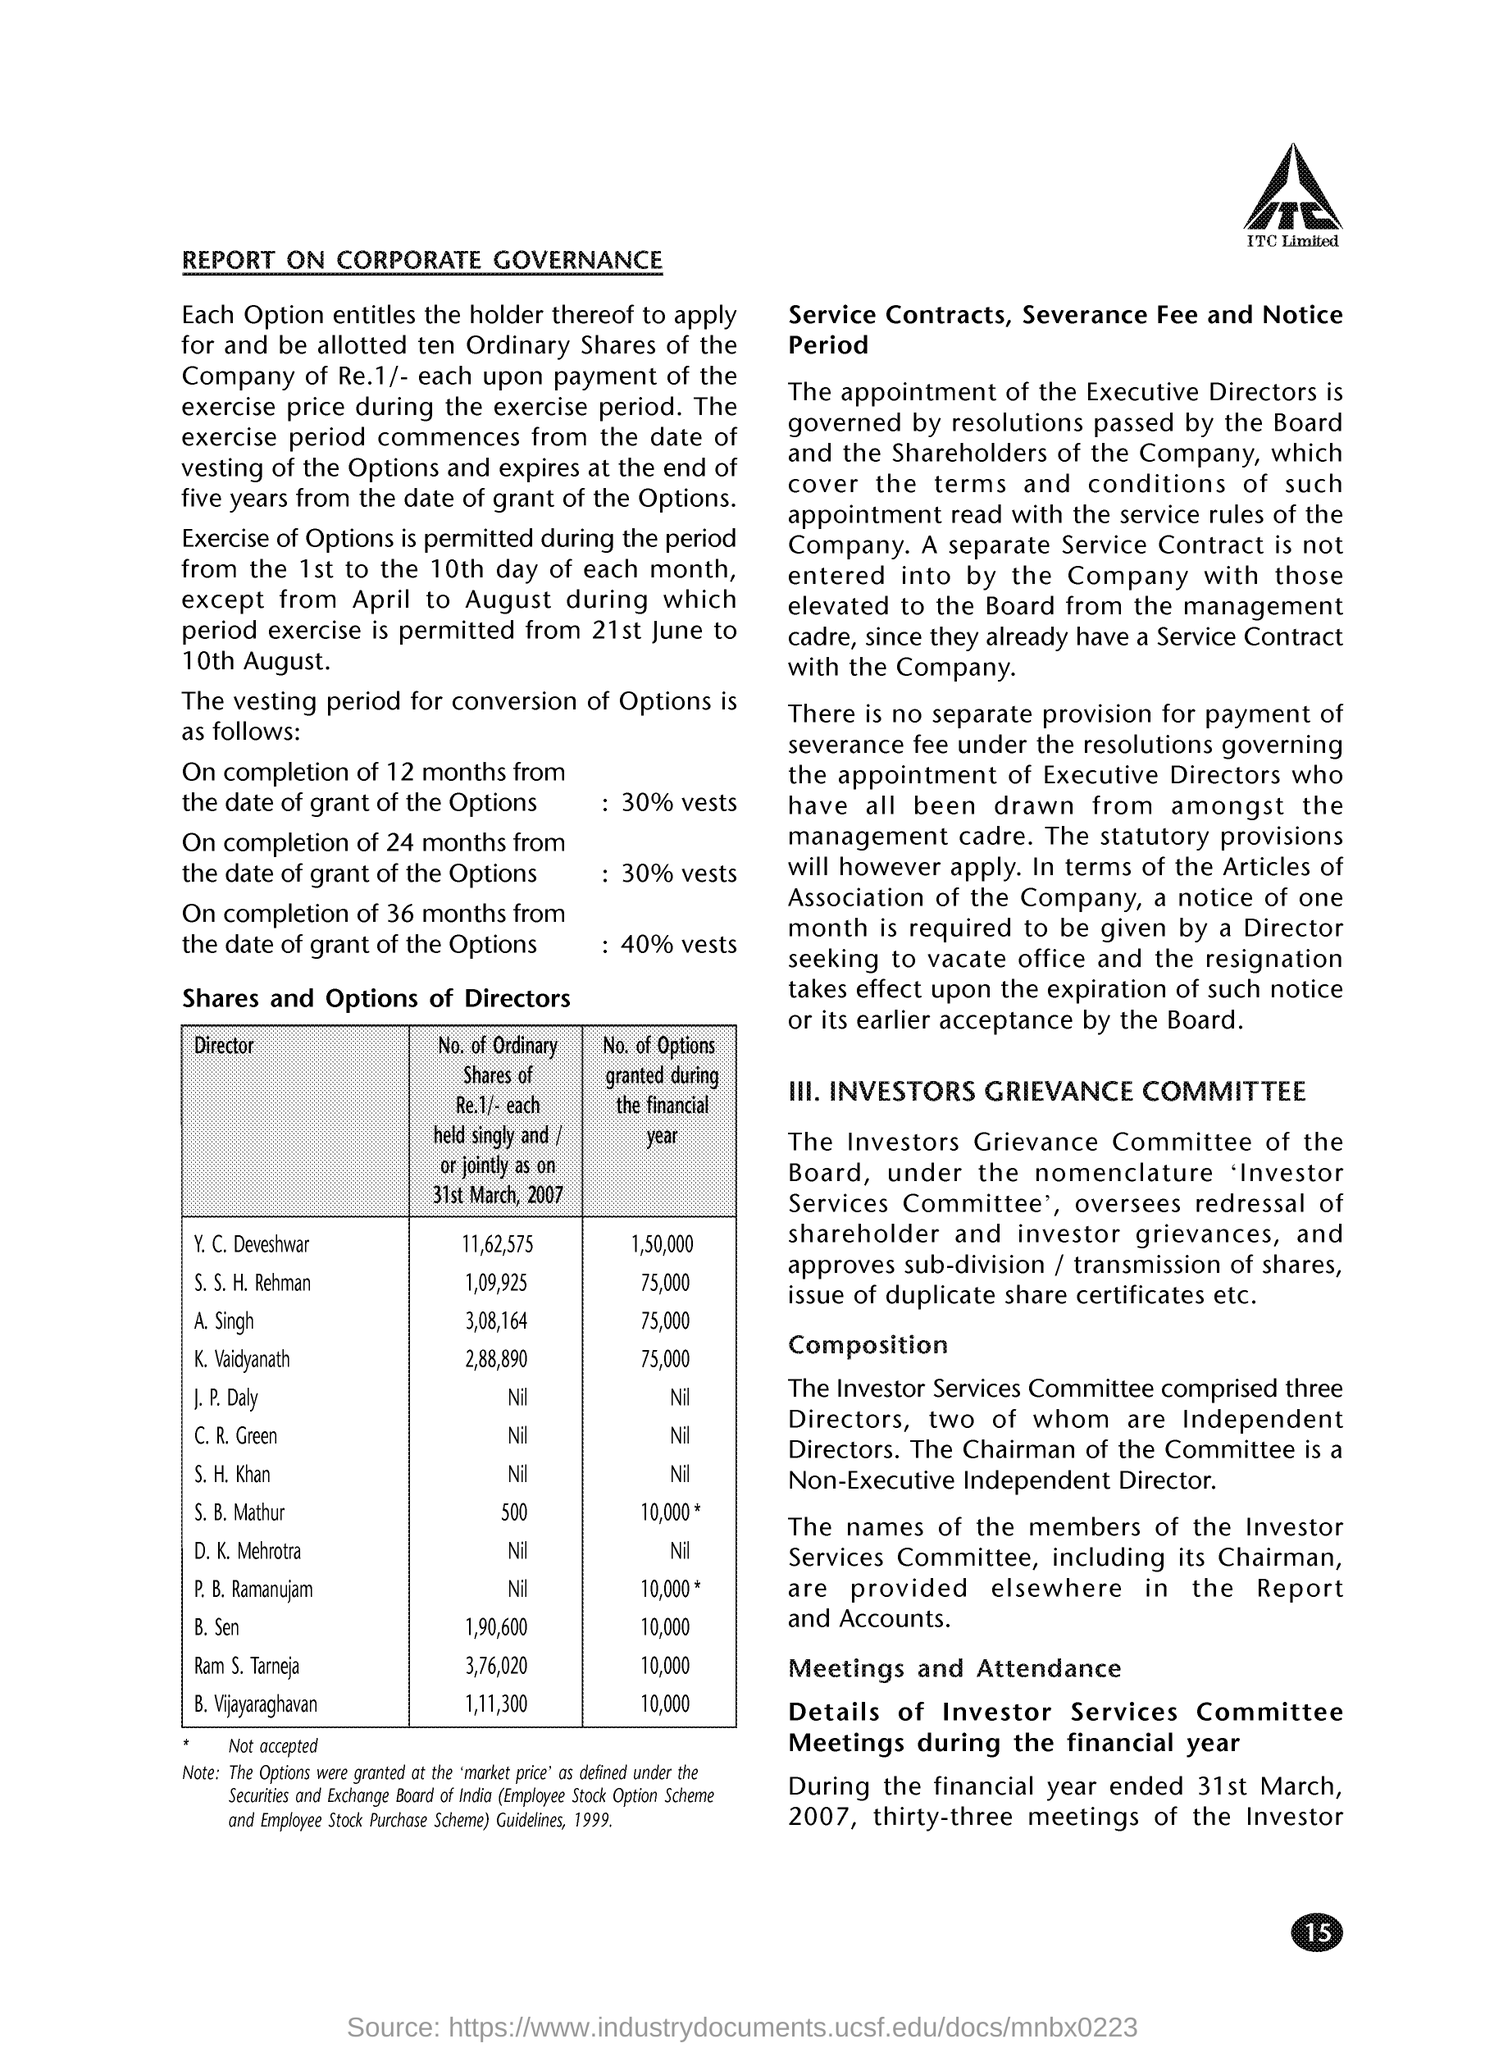What are the No. of Options granted during the financial year for Y. C. Deveshwar?
Provide a succinct answer. 1,50,000. What are the No. of Options granted during the financial year for S. S. H. Rehman?
Make the answer very short. 75,000. What are the No. of Options granted during the financial year for A. Singh?
Provide a succinct answer. 75,000. What are the No. of Options granted during the financial year for K. Vaidyanathan?
Make the answer very short. 75,000. What are the No. of Options granted during the financial year for S. B. Mathur?
Keep it short and to the point. 10,000*. What are the No. of Options granted during the financial year for B. Sen?
Keep it short and to the point. 10,000. What are the No. of Options granted during the financial year for B. Vijayaraghavan?
Your answer should be very brief. 10,000. What are the No. of Options granted during the financial year for Ram S. Tarneja?
Ensure brevity in your answer.  10,000. What are the No. of Ordinary shares of Re.1/- each held singly and / or jointly as on 31st March, 2007 for Y. C. Deveshwar?
Make the answer very short. 11,62,575. What are the No. of Ordinary shares of Re.1/- each held singly and / or jointly as on 31st March, 2007 for A. Singh?
Ensure brevity in your answer.  3,08,164. 